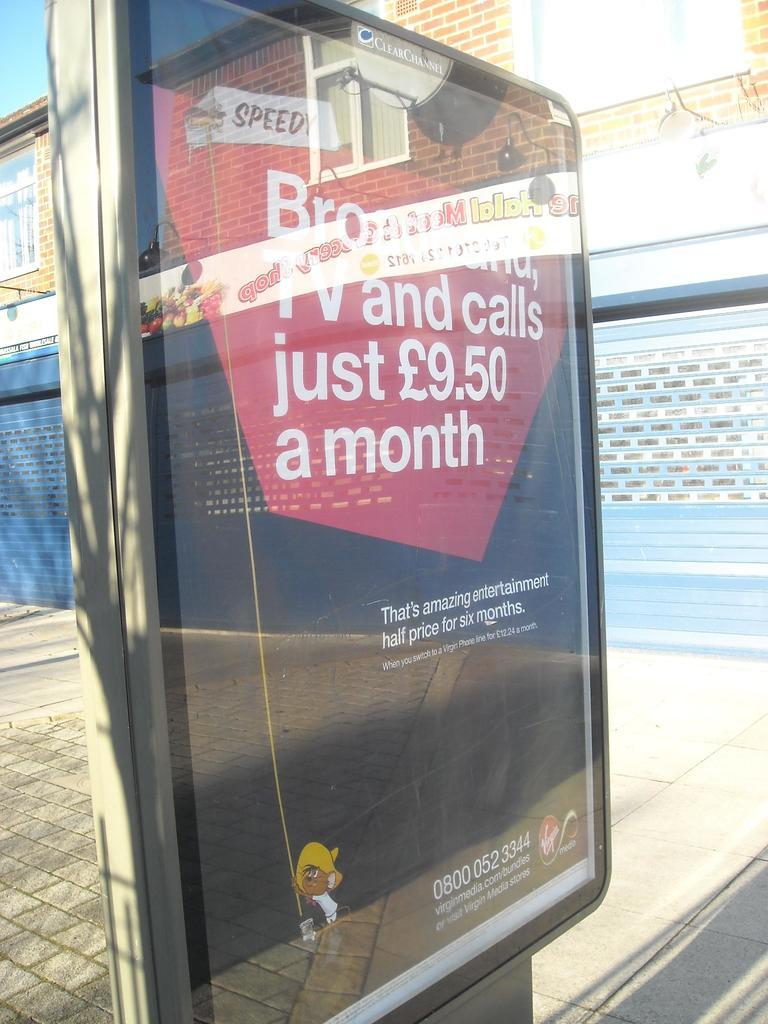What type of material is used to make the led board in the image? The led board in the image is made up of glass. What type of building can be seen in the image? There is a building made up of bricks in the image. What type of path is visible in the image? There is a footpath in the image. What is the color of the sky in the image? The sky is pale blue in the image. What type of fruit is hanging from the led board in the image? There is no fruit hanging from the led board in the image; it is made up of glass. How many daughters are present in the image? There is no mention of a daughter or any people in the image. 